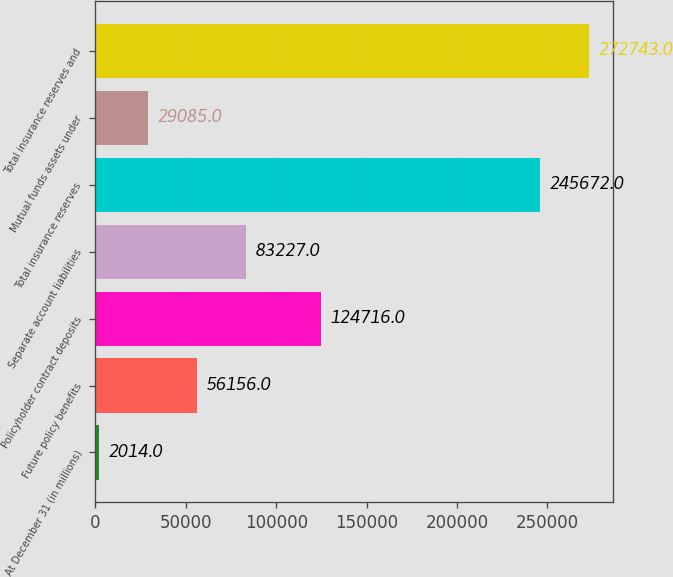Convert chart. <chart><loc_0><loc_0><loc_500><loc_500><bar_chart><fcel>At December 31 (in millions)<fcel>Future policy benefits<fcel>Policyholder contract deposits<fcel>Separate account liabilities<fcel>Total insurance reserves<fcel>Mutual funds assets under<fcel>Total insurance reserves and<nl><fcel>2014<fcel>56156<fcel>124716<fcel>83227<fcel>245672<fcel>29085<fcel>272743<nl></chart> 